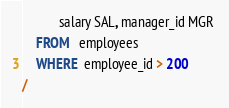Convert code to text. <code><loc_0><loc_0><loc_500><loc_500><_SQL_>           salary SAL, manager_id MGR 
    FROM   employees
    WHERE  employee_id > 200
/
</code> 